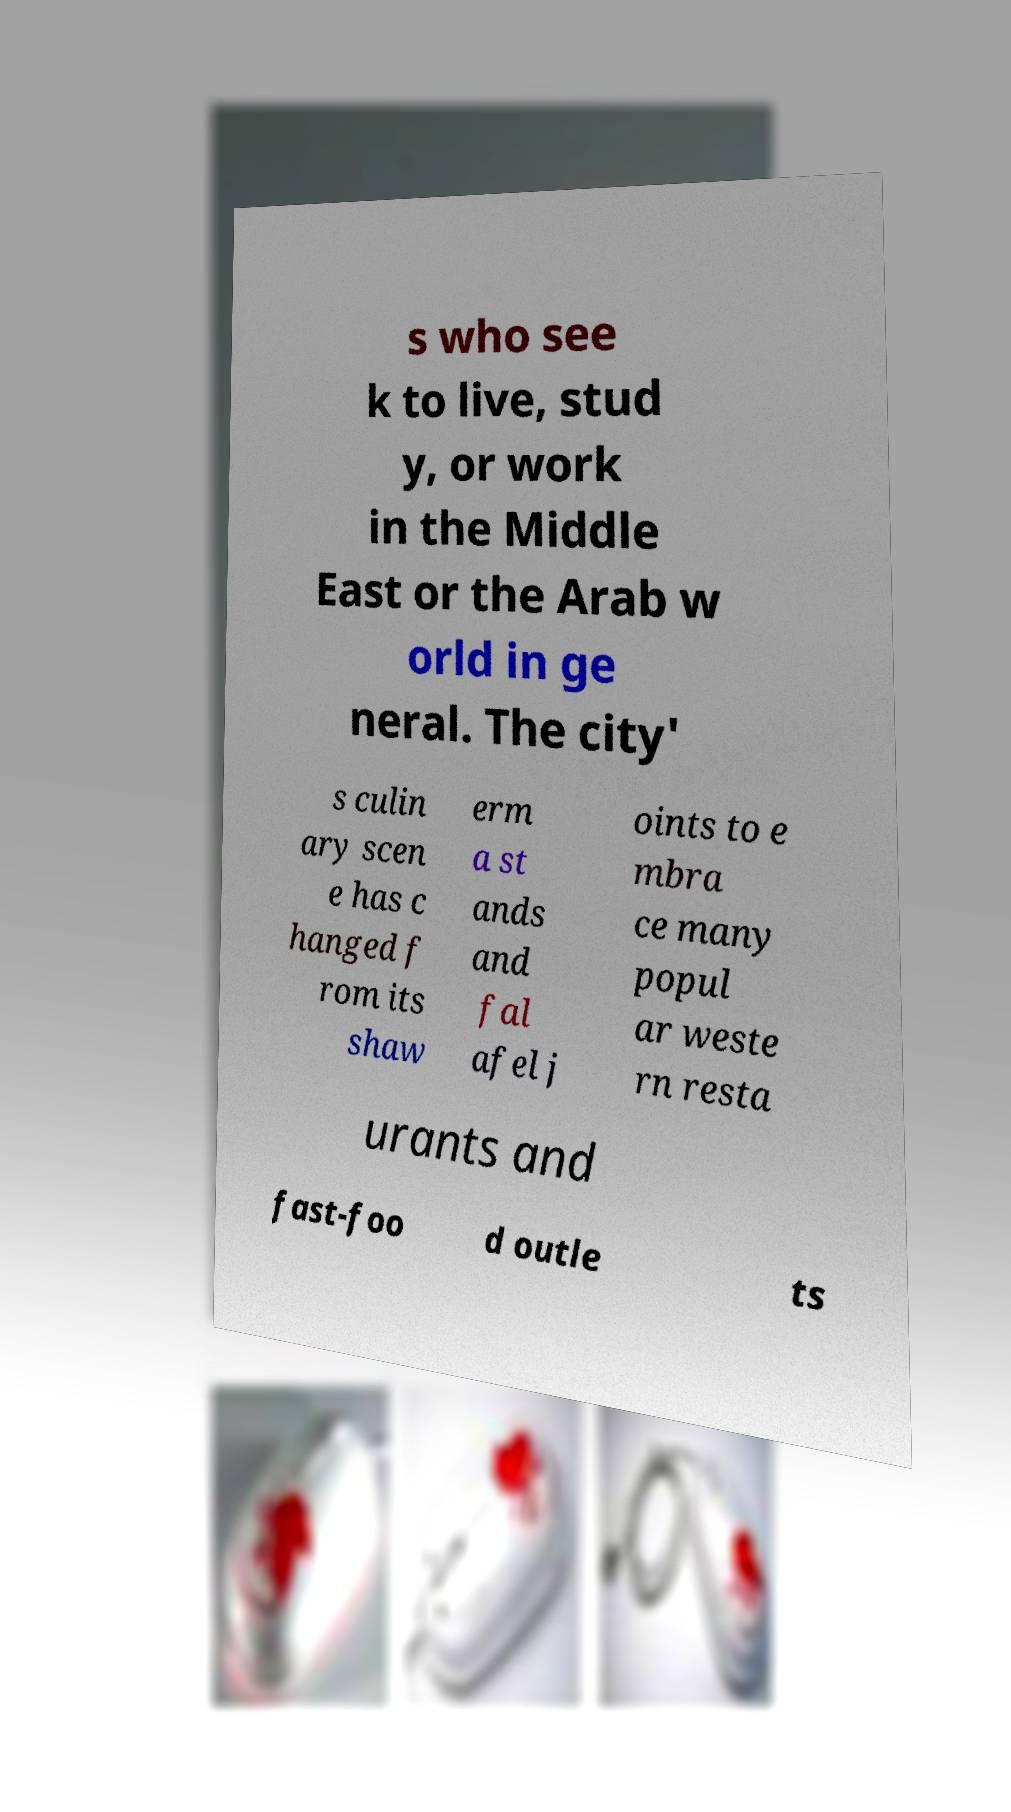Could you assist in decoding the text presented in this image and type it out clearly? s who see k to live, stud y, or work in the Middle East or the Arab w orld in ge neral. The city' s culin ary scen e has c hanged f rom its shaw erm a st ands and fal afel j oints to e mbra ce many popul ar weste rn resta urants and fast-foo d outle ts 